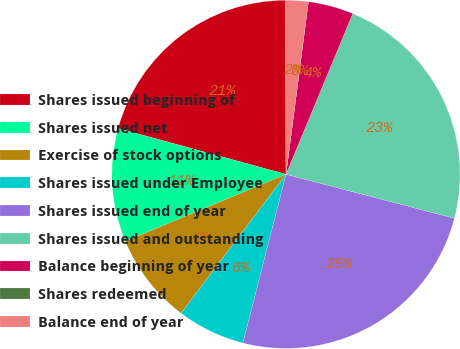Convert chart to OTSL. <chart><loc_0><loc_0><loc_500><loc_500><pie_chart><fcel>Shares issued beginning of<fcel>Shares issued net<fcel>Exercise of stock options<fcel>Shares issued under Employee<fcel>Shares issued end of year<fcel>Shares issued and outstanding<fcel>Balance beginning of year<fcel>Shares redeemed<fcel>Balance end of year<nl><fcel>20.7%<fcel>10.53%<fcel>8.42%<fcel>6.32%<fcel>24.91%<fcel>22.8%<fcel>4.21%<fcel>0.0%<fcel>2.11%<nl></chart> 